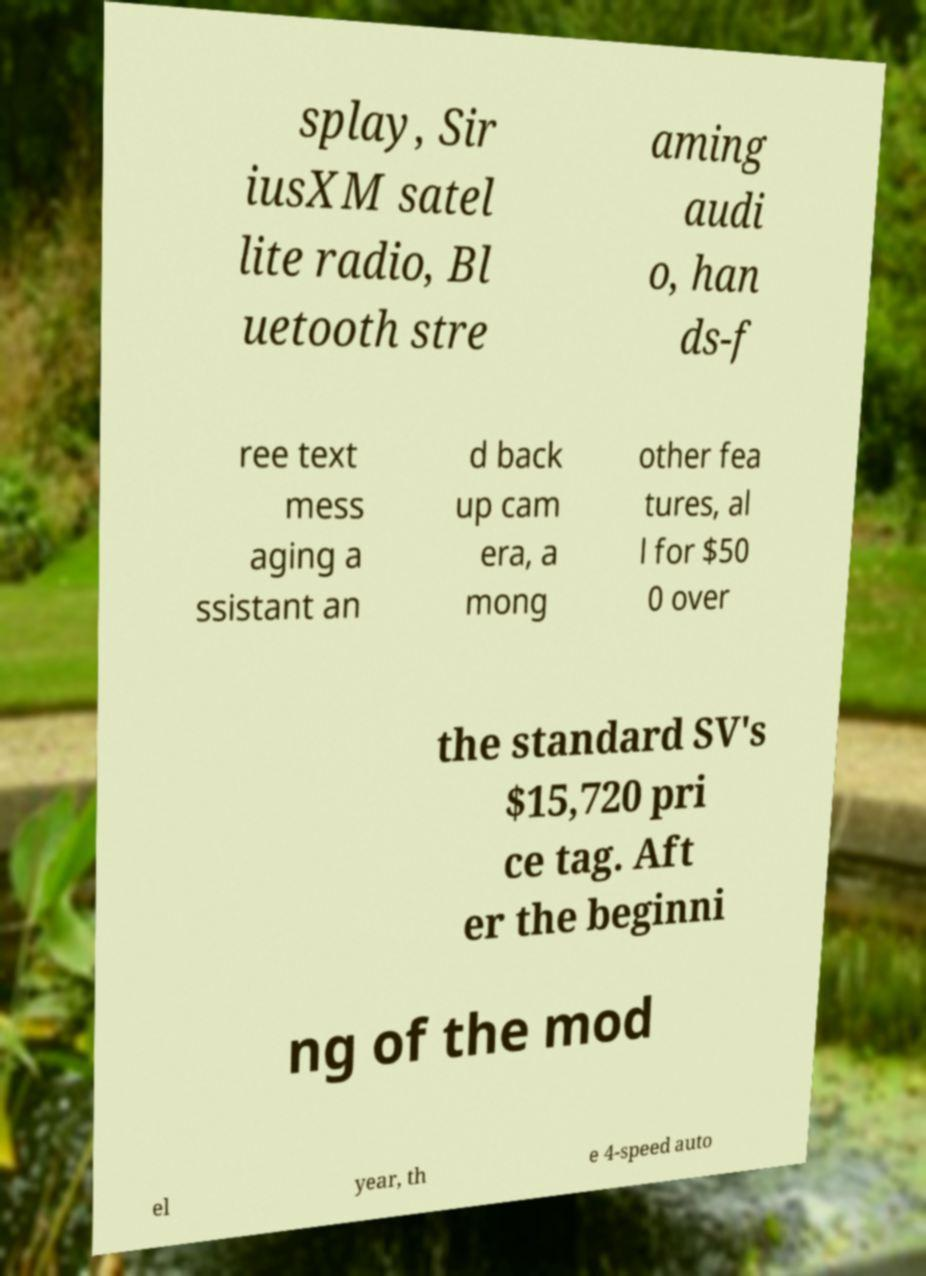Please read and relay the text visible in this image. What does it say? splay, Sir iusXM satel lite radio, Bl uetooth stre aming audi o, han ds-f ree text mess aging a ssistant an d back up cam era, a mong other fea tures, al l for $50 0 over the standard SV's $15,720 pri ce tag. Aft er the beginni ng of the mod el year, th e 4-speed auto 